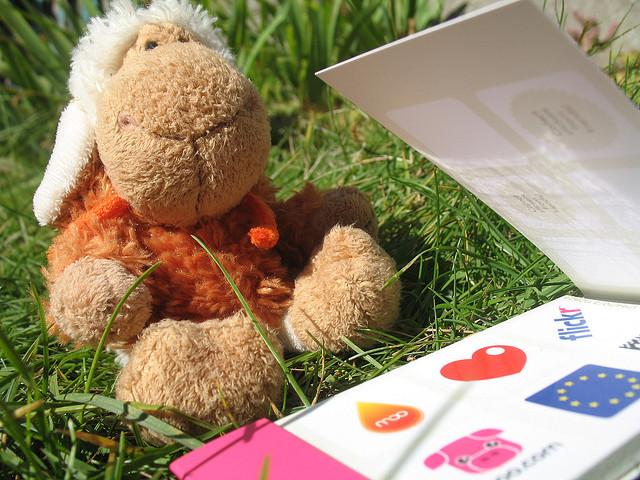What is the toy sitting on?
Concise answer only. Grass. Is the stuffed animal reading the book?
Give a very brief answer. No. Where is the photo album?
Concise answer only. On grass. 